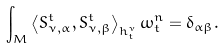Convert formula to latex. <formula><loc_0><loc_0><loc_500><loc_500>\int _ { M } \left < S _ { \nu , \alpha } ^ { t } , S _ { \nu , \beta } ^ { t } \right > _ { h _ { t } ^ { \nu } } \omega _ { t } ^ { n } = \delta _ { \alpha \beta } .</formula> 